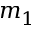<formula> <loc_0><loc_0><loc_500><loc_500>m _ { 1 }</formula> 